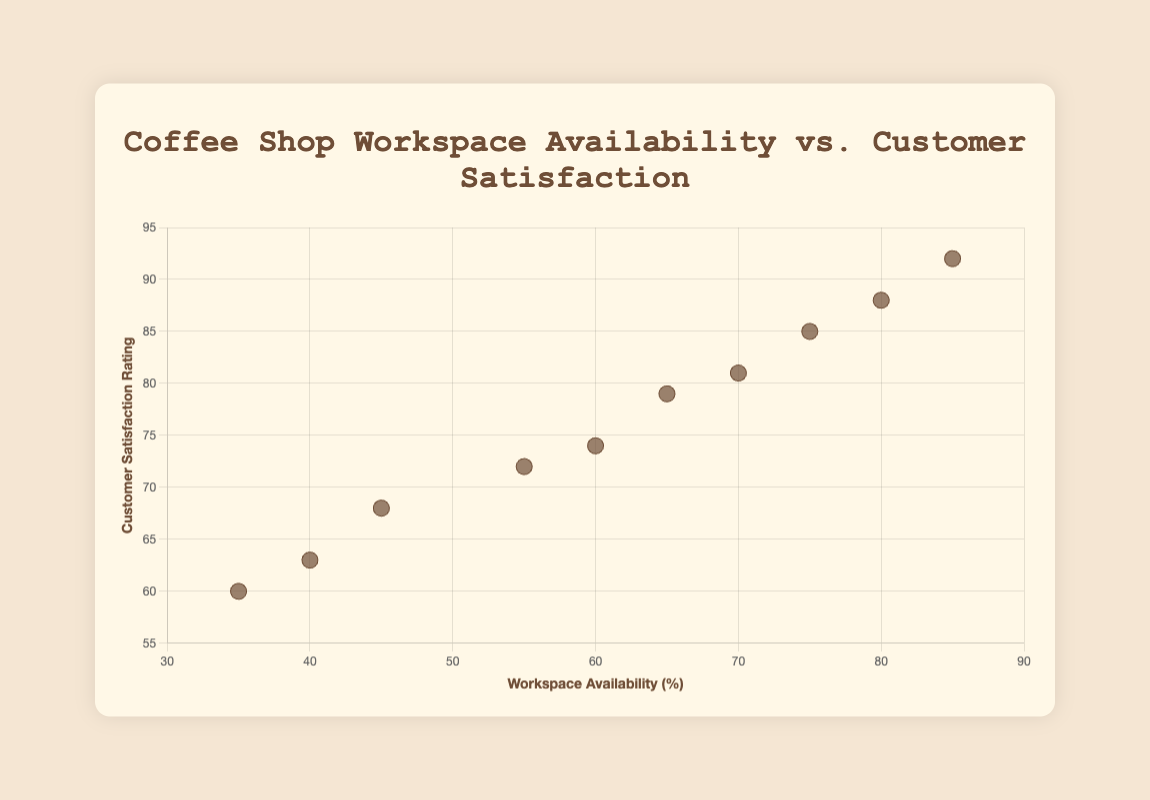How many coffee shops are represented in the scatter plot? Count the number of data points shown in the scatter plot. Each data point represents a coffee shop.
Answer: 10 What is the title of the scatter plot? Read the text displayed at the top of the scatter plot.
Answer: Coffee Shop Workspace Availability vs. Customer Satisfaction Which coffee shop has the highest workspace availability percentage? Locate the data point with the highest value on the x-axis and identify the corresponding coffee shop.
Answer: Blue Bottle Coffee What is the customer satisfaction rating for Sightglass Coffee? Find the data point labeled Sightglass Coffee and check the y-axis value corresponding to it.
Answer: 68 Among the coffee shops with over 70% workspace availability, which one has the lowest customer satisfaction rating? Identify points where the x-value is more than 70, then compare their y-values to find the lowest one.
Answer: Starbucks Is there a general trend between workspace availability and customer satisfaction? Observe the overall distribution pattern of the data points. Determine if there is an upward or downward trend.
Answer: Positively correlated What is the average workspace availability percentage for all the coffee shops? Sum up the workspace availability percentages for all data points and divide by the number of points (10). (85 + 70 + 60 + 45 + 75 + 40 + 65 + 55 + 80 + 35) / 10 = 61
Answer: 61 Which coffee shop has both a workspace availability percentage below 50 and a customer satisfaction rating below 65? Identify data points where both x and y values are below 50 and 65, respectively.
Answer: Four Barrel Coffee and Ritual Coffee Roasters Between Andytown Coffee Roasters and Blue Bottle Coffee, which has a higher customer satisfaction rating, and by how much? Compare the y-values of Andytown Coffee Roasters and Blue Bottle Coffee and subtract the smaller value from the larger one. 92 - 88 = 4
Answer: Blue Bottle Coffee, by 4 Which coffee shop is represented by the data point at (35%, 60%)? Find the data point with x = 35 and y = 60 and determine the corresponding coffee shop.
Answer: Four Barrel Coffee 